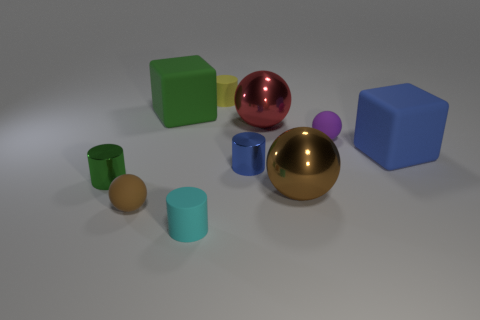There is a big brown thing; what shape is it?
Your answer should be compact. Sphere. What number of tiny brown cubes are the same material as the big red sphere?
Provide a short and direct response. 0. How many tiny purple rubber things are there?
Your answer should be compact. 1. The tiny sphere in front of the blue thing to the right of the big ball behind the blue metal cylinder is what color?
Provide a succinct answer. Brown. Is the material of the small blue cylinder the same as the brown thing right of the yellow object?
Provide a succinct answer. Yes. What is the material of the yellow cylinder?
Keep it short and to the point. Rubber. What number of other objects are there of the same material as the red ball?
Your response must be concise. 3. What is the shape of the rubber thing that is both behind the brown metallic object and left of the small yellow cylinder?
Your response must be concise. Cube. What is the color of the small ball that is made of the same material as the tiny brown object?
Give a very brief answer. Purple. Are there the same number of tiny purple matte objects that are right of the blue matte cube and things?
Ensure brevity in your answer.  No. 